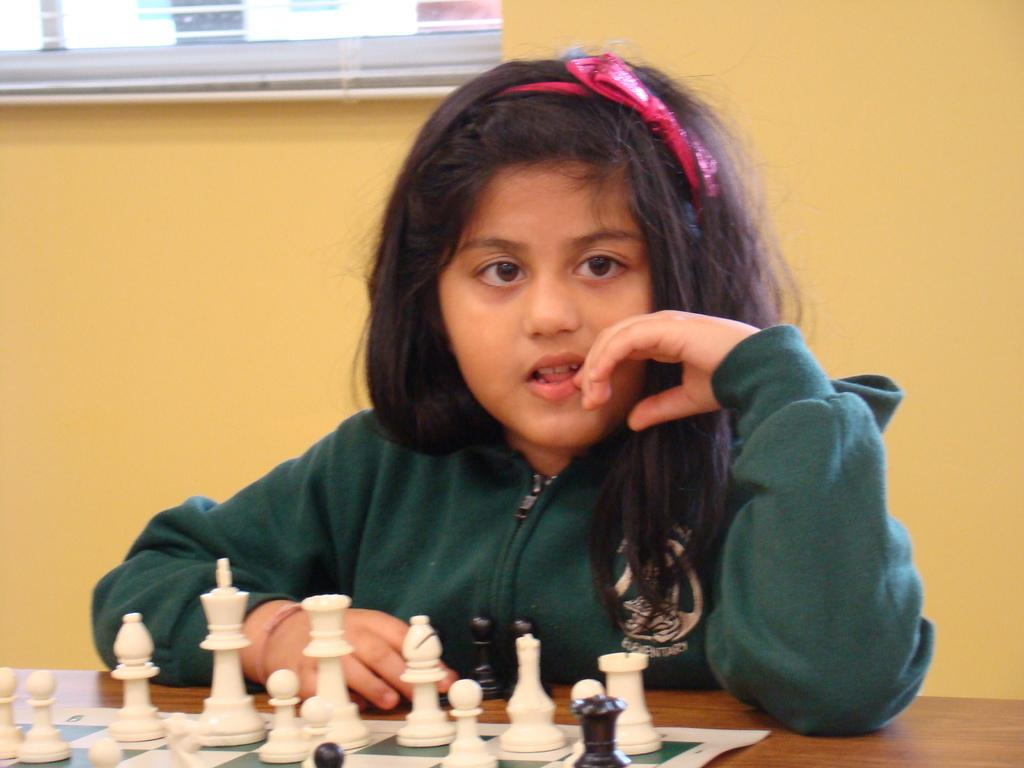What is the girl in the image doing? The girl is sitting in the image. What game is being played in the image? There are chess coins in the image, and they are on a chess board on a table. What can be seen through the window in the image? The window is visible in the image, but the view through it is not described in the facts. What is the background of the image made of? There is a wall in the image, which suggests that the background is made of a solid material. What is the temperature outside during the summer season in the image? The facts provided do not mention the temperature or the season, so it is impossible to answer this question based on the information given. 